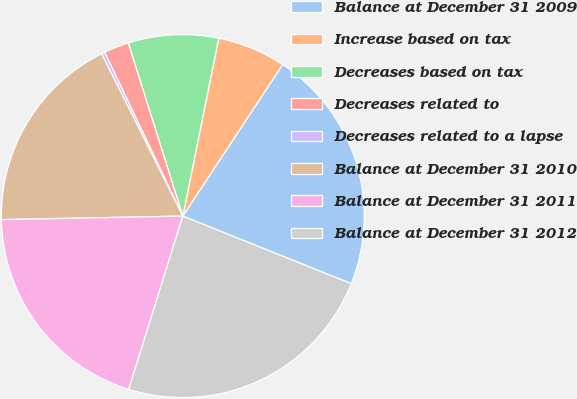Convert chart to OTSL. <chart><loc_0><loc_0><loc_500><loc_500><pie_chart><fcel>Balance at December 31 2009<fcel>Increase based on tax<fcel>Decreases based on tax<fcel>Decreases related to<fcel>Decreases related to a lapse<fcel>Balance at December 31 2010<fcel>Balance at December 31 2011<fcel>Balance at December 31 2012<nl><fcel>21.8%<fcel>6.1%<fcel>8.03%<fcel>2.23%<fcel>0.29%<fcel>17.93%<fcel>19.87%<fcel>23.74%<nl></chart> 